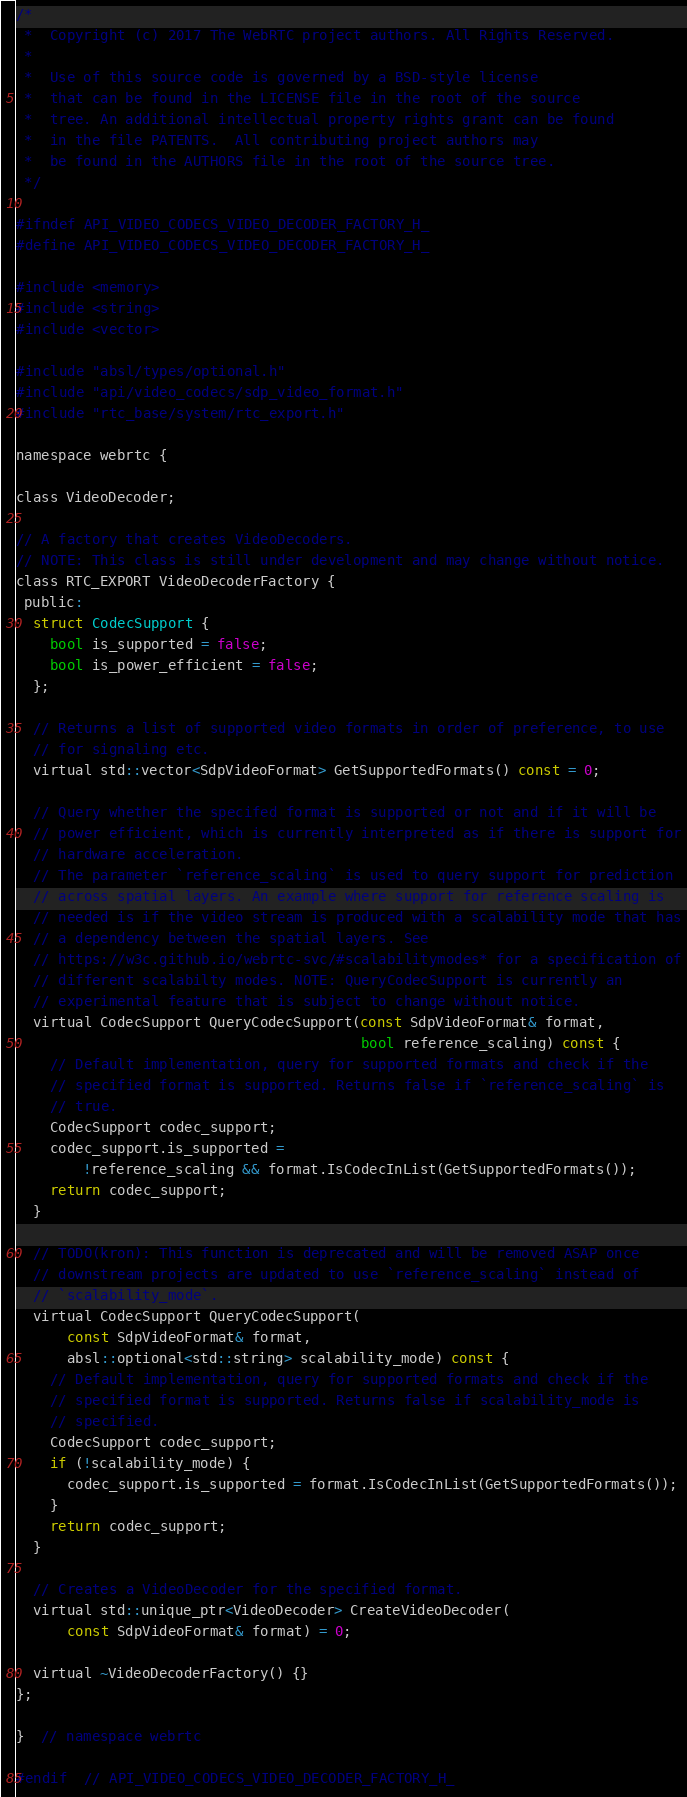<code> <loc_0><loc_0><loc_500><loc_500><_C_>/*
 *  Copyright (c) 2017 The WebRTC project authors. All Rights Reserved.
 *
 *  Use of this source code is governed by a BSD-style license
 *  that can be found in the LICENSE file in the root of the source
 *  tree. An additional intellectual property rights grant can be found
 *  in the file PATENTS.  All contributing project authors may
 *  be found in the AUTHORS file in the root of the source tree.
 */

#ifndef API_VIDEO_CODECS_VIDEO_DECODER_FACTORY_H_
#define API_VIDEO_CODECS_VIDEO_DECODER_FACTORY_H_

#include <memory>
#include <string>
#include <vector>

#include "absl/types/optional.h"
#include "api/video_codecs/sdp_video_format.h"
#include "rtc_base/system/rtc_export.h"

namespace webrtc {

class VideoDecoder;

// A factory that creates VideoDecoders.
// NOTE: This class is still under development and may change without notice.
class RTC_EXPORT VideoDecoderFactory {
 public:
  struct CodecSupport {
    bool is_supported = false;
    bool is_power_efficient = false;
  };

  // Returns a list of supported video formats in order of preference, to use
  // for signaling etc.
  virtual std::vector<SdpVideoFormat> GetSupportedFormats() const = 0;

  // Query whether the specifed format is supported or not and if it will be
  // power efficient, which is currently interpreted as if there is support for
  // hardware acceleration.
  // The parameter `reference_scaling` is used to query support for prediction
  // across spatial layers. An example where support for reference scaling is
  // needed is if the video stream is produced with a scalability mode that has
  // a dependency between the spatial layers. See
  // https://w3c.github.io/webrtc-svc/#scalabilitymodes* for a specification of
  // different scalabilty modes. NOTE: QueryCodecSupport is currently an
  // experimental feature that is subject to change without notice.
  virtual CodecSupport QueryCodecSupport(const SdpVideoFormat& format,
                                         bool reference_scaling) const {
    // Default implementation, query for supported formats and check if the
    // specified format is supported. Returns false if `reference_scaling` is
    // true.
    CodecSupport codec_support;
    codec_support.is_supported =
        !reference_scaling && format.IsCodecInList(GetSupportedFormats());
    return codec_support;
  }

  // TODO(kron): This function is deprecated and will be removed ASAP once
  // downstream projects are updated to use `reference_scaling` instead of
  // `scalability_mode`.
  virtual CodecSupport QueryCodecSupport(
      const SdpVideoFormat& format,
      absl::optional<std::string> scalability_mode) const {
    // Default implementation, query for supported formats and check if the
    // specified format is supported. Returns false if scalability_mode is
    // specified.
    CodecSupport codec_support;
    if (!scalability_mode) {
      codec_support.is_supported = format.IsCodecInList(GetSupportedFormats());
    }
    return codec_support;
  }

  // Creates a VideoDecoder for the specified format.
  virtual std::unique_ptr<VideoDecoder> CreateVideoDecoder(
      const SdpVideoFormat& format) = 0;

  virtual ~VideoDecoderFactory() {}
};

}  // namespace webrtc

#endif  // API_VIDEO_CODECS_VIDEO_DECODER_FACTORY_H_
</code> 